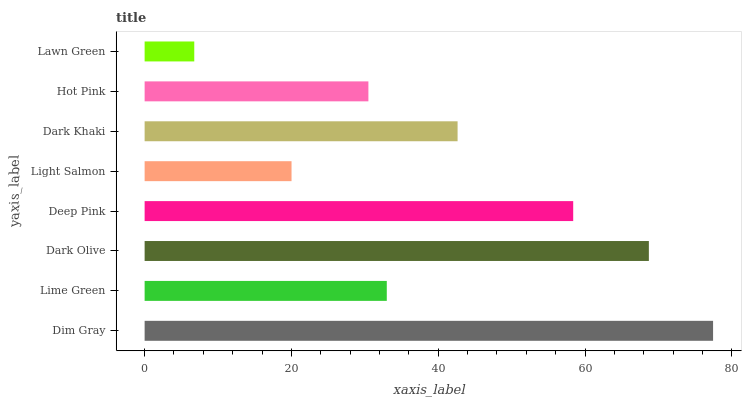Is Lawn Green the minimum?
Answer yes or no. Yes. Is Dim Gray the maximum?
Answer yes or no. Yes. Is Lime Green the minimum?
Answer yes or no. No. Is Lime Green the maximum?
Answer yes or no. No. Is Dim Gray greater than Lime Green?
Answer yes or no. Yes. Is Lime Green less than Dim Gray?
Answer yes or no. Yes. Is Lime Green greater than Dim Gray?
Answer yes or no. No. Is Dim Gray less than Lime Green?
Answer yes or no. No. Is Dark Khaki the high median?
Answer yes or no. Yes. Is Lime Green the low median?
Answer yes or no. Yes. Is Light Salmon the high median?
Answer yes or no. No. Is Dim Gray the low median?
Answer yes or no. No. 